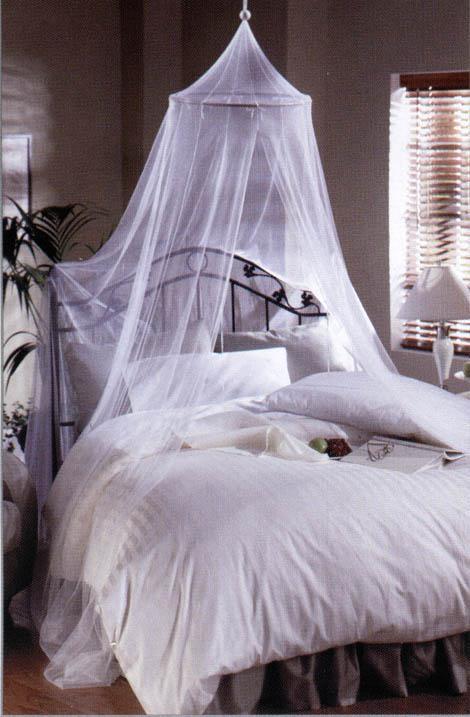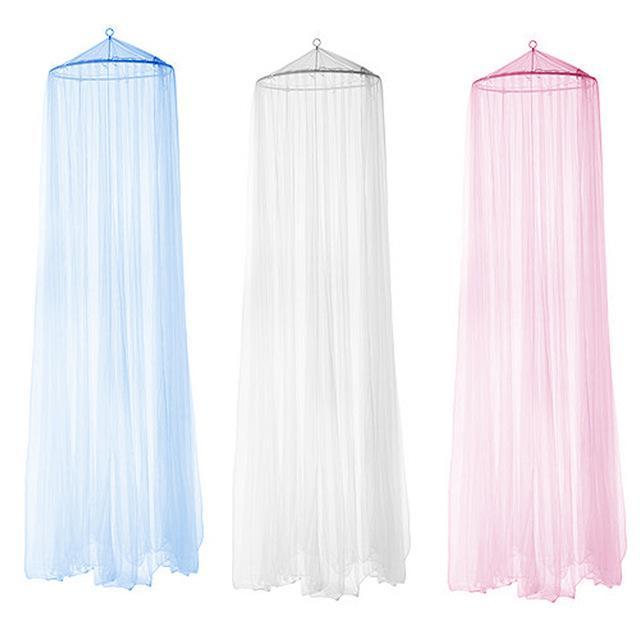The first image is the image on the left, the second image is the image on the right. Evaluate the accuracy of this statement regarding the images: "There are two bed with two white canopies.". Is it true? Answer yes or no. No. The first image is the image on the left, the second image is the image on the right. Analyze the images presented: Is the assertion "The right image shows at least one bed canopy, but no bed is shown." valid? Answer yes or no. Yes. 